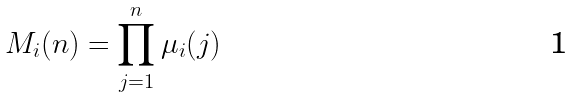Convert formula to latex. <formula><loc_0><loc_0><loc_500><loc_500>M _ { i } ( n ) = \prod _ { j = 1 } ^ { n } \mu _ { i } ( j )</formula> 